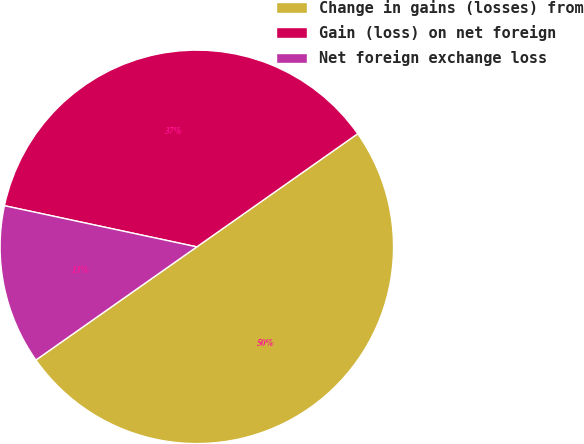<chart> <loc_0><loc_0><loc_500><loc_500><pie_chart><fcel>Change in gains (losses) from<fcel>Gain (loss) on net foreign<fcel>Net foreign exchange loss<nl><fcel>50.0%<fcel>36.89%<fcel>13.11%<nl></chart> 